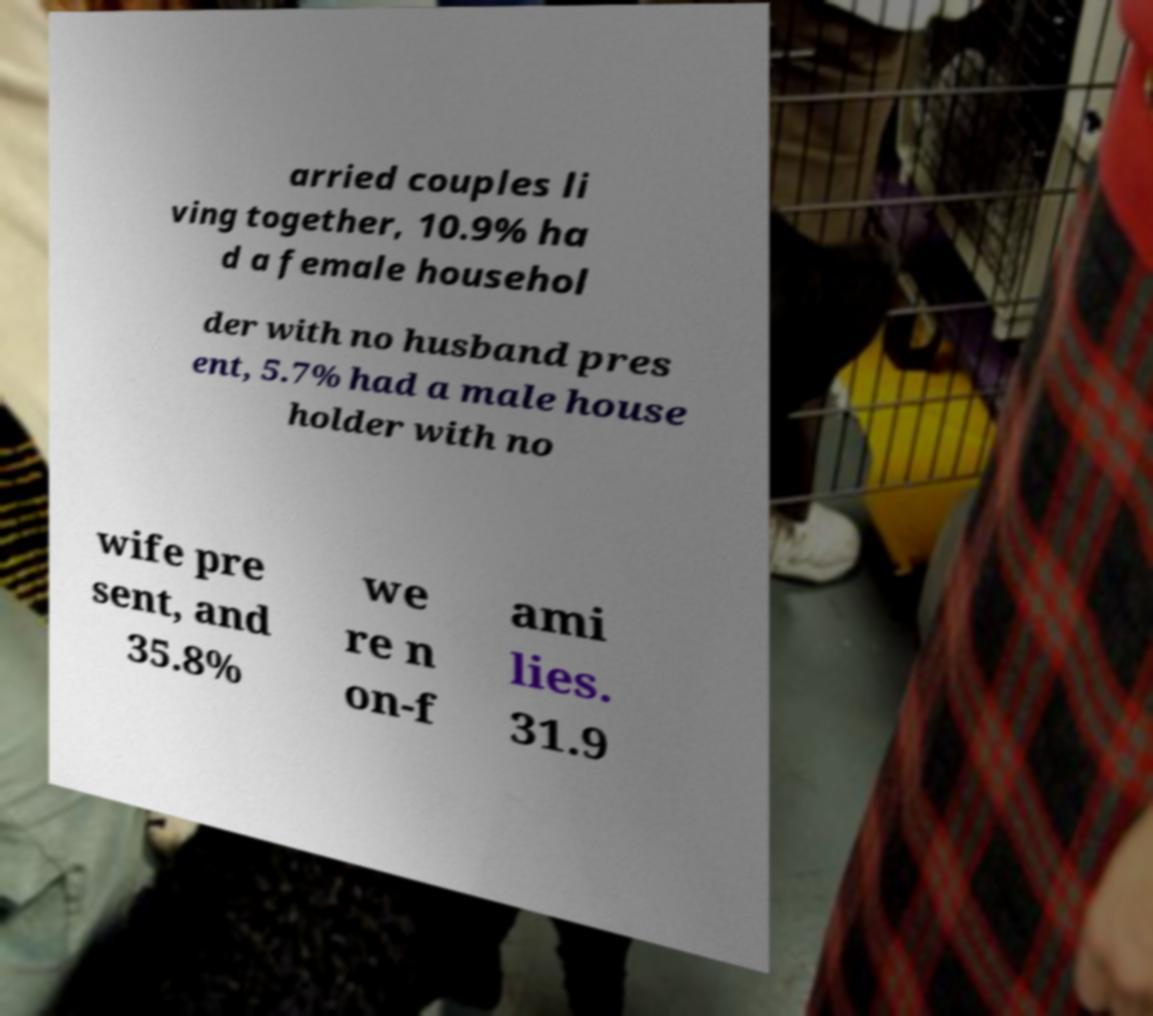Could you extract and type out the text from this image? arried couples li ving together, 10.9% ha d a female househol der with no husband pres ent, 5.7% had a male house holder with no wife pre sent, and 35.8% we re n on-f ami lies. 31.9 